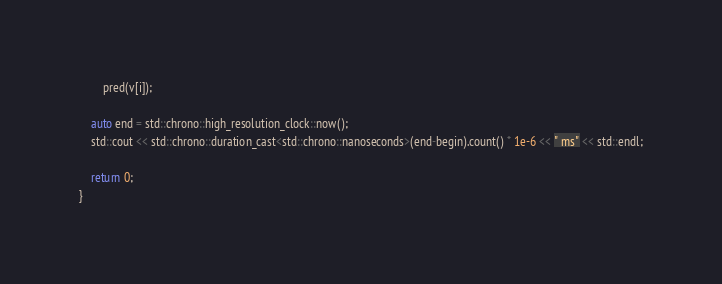Convert code to text. <code><loc_0><loc_0><loc_500><loc_500><_C++_>   		pred(v[i]);

    auto end = std::chrono::high_resolution_clock::now();
    std::cout << std::chrono::duration_cast<std::chrono::nanoseconds>(end-begin).count() * 1e-6 << " ms" << std::endl;

    return 0;
}
</code> 